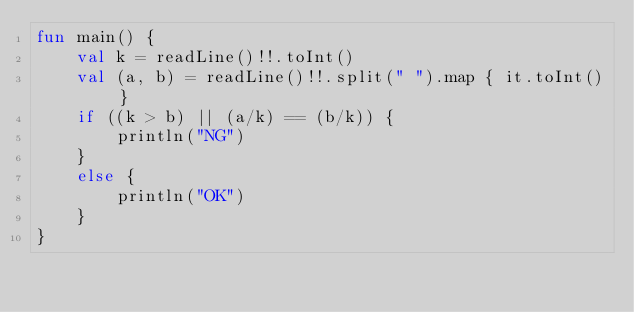Convert code to text. <code><loc_0><loc_0><loc_500><loc_500><_Kotlin_>fun main() {
    val k = readLine()!!.toInt()
    val (a, b) = readLine()!!.split(" ").map { it.toInt() }
    if ((k > b) || (a/k) == (b/k)) {
        println("NG")
    }
    else {
        println("OK")
    }
}</code> 